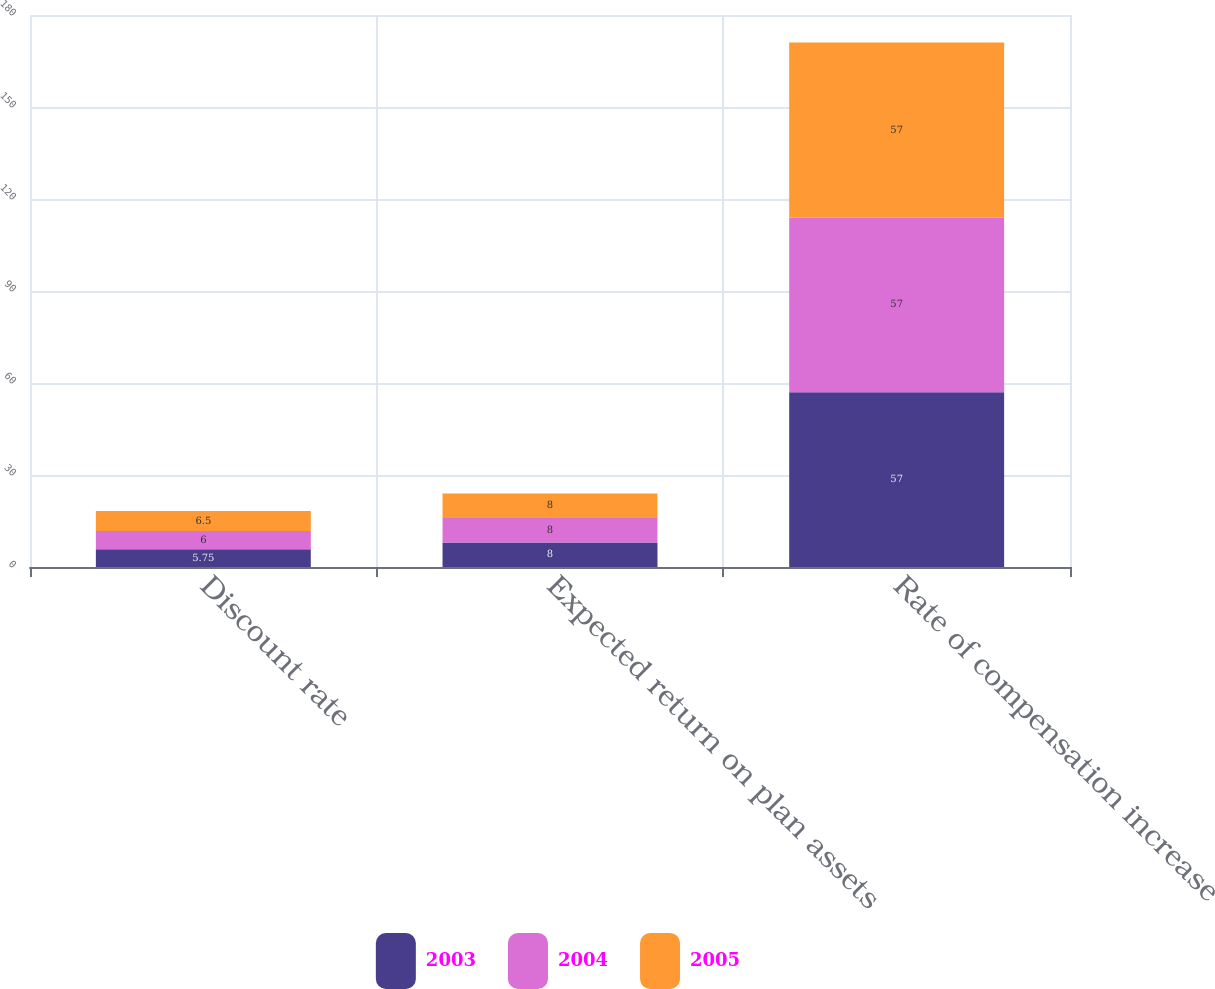Convert chart to OTSL. <chart><loc_0><loc_0><loc_500><loc_500><stacked_bar_chart><ecel><fcel>Discount rate<fcel>Expected return on plan assets<fcel>Rate of compensation increase<nl><fcel>2003<fcel>5.75<fcel>8<fcel>57<nl><fcel>2004<fcel>6<fcel>8<fcel>57<nl><fcel>2005<fcel>6.5<fcel>8<fcel>57<nl></chart> 